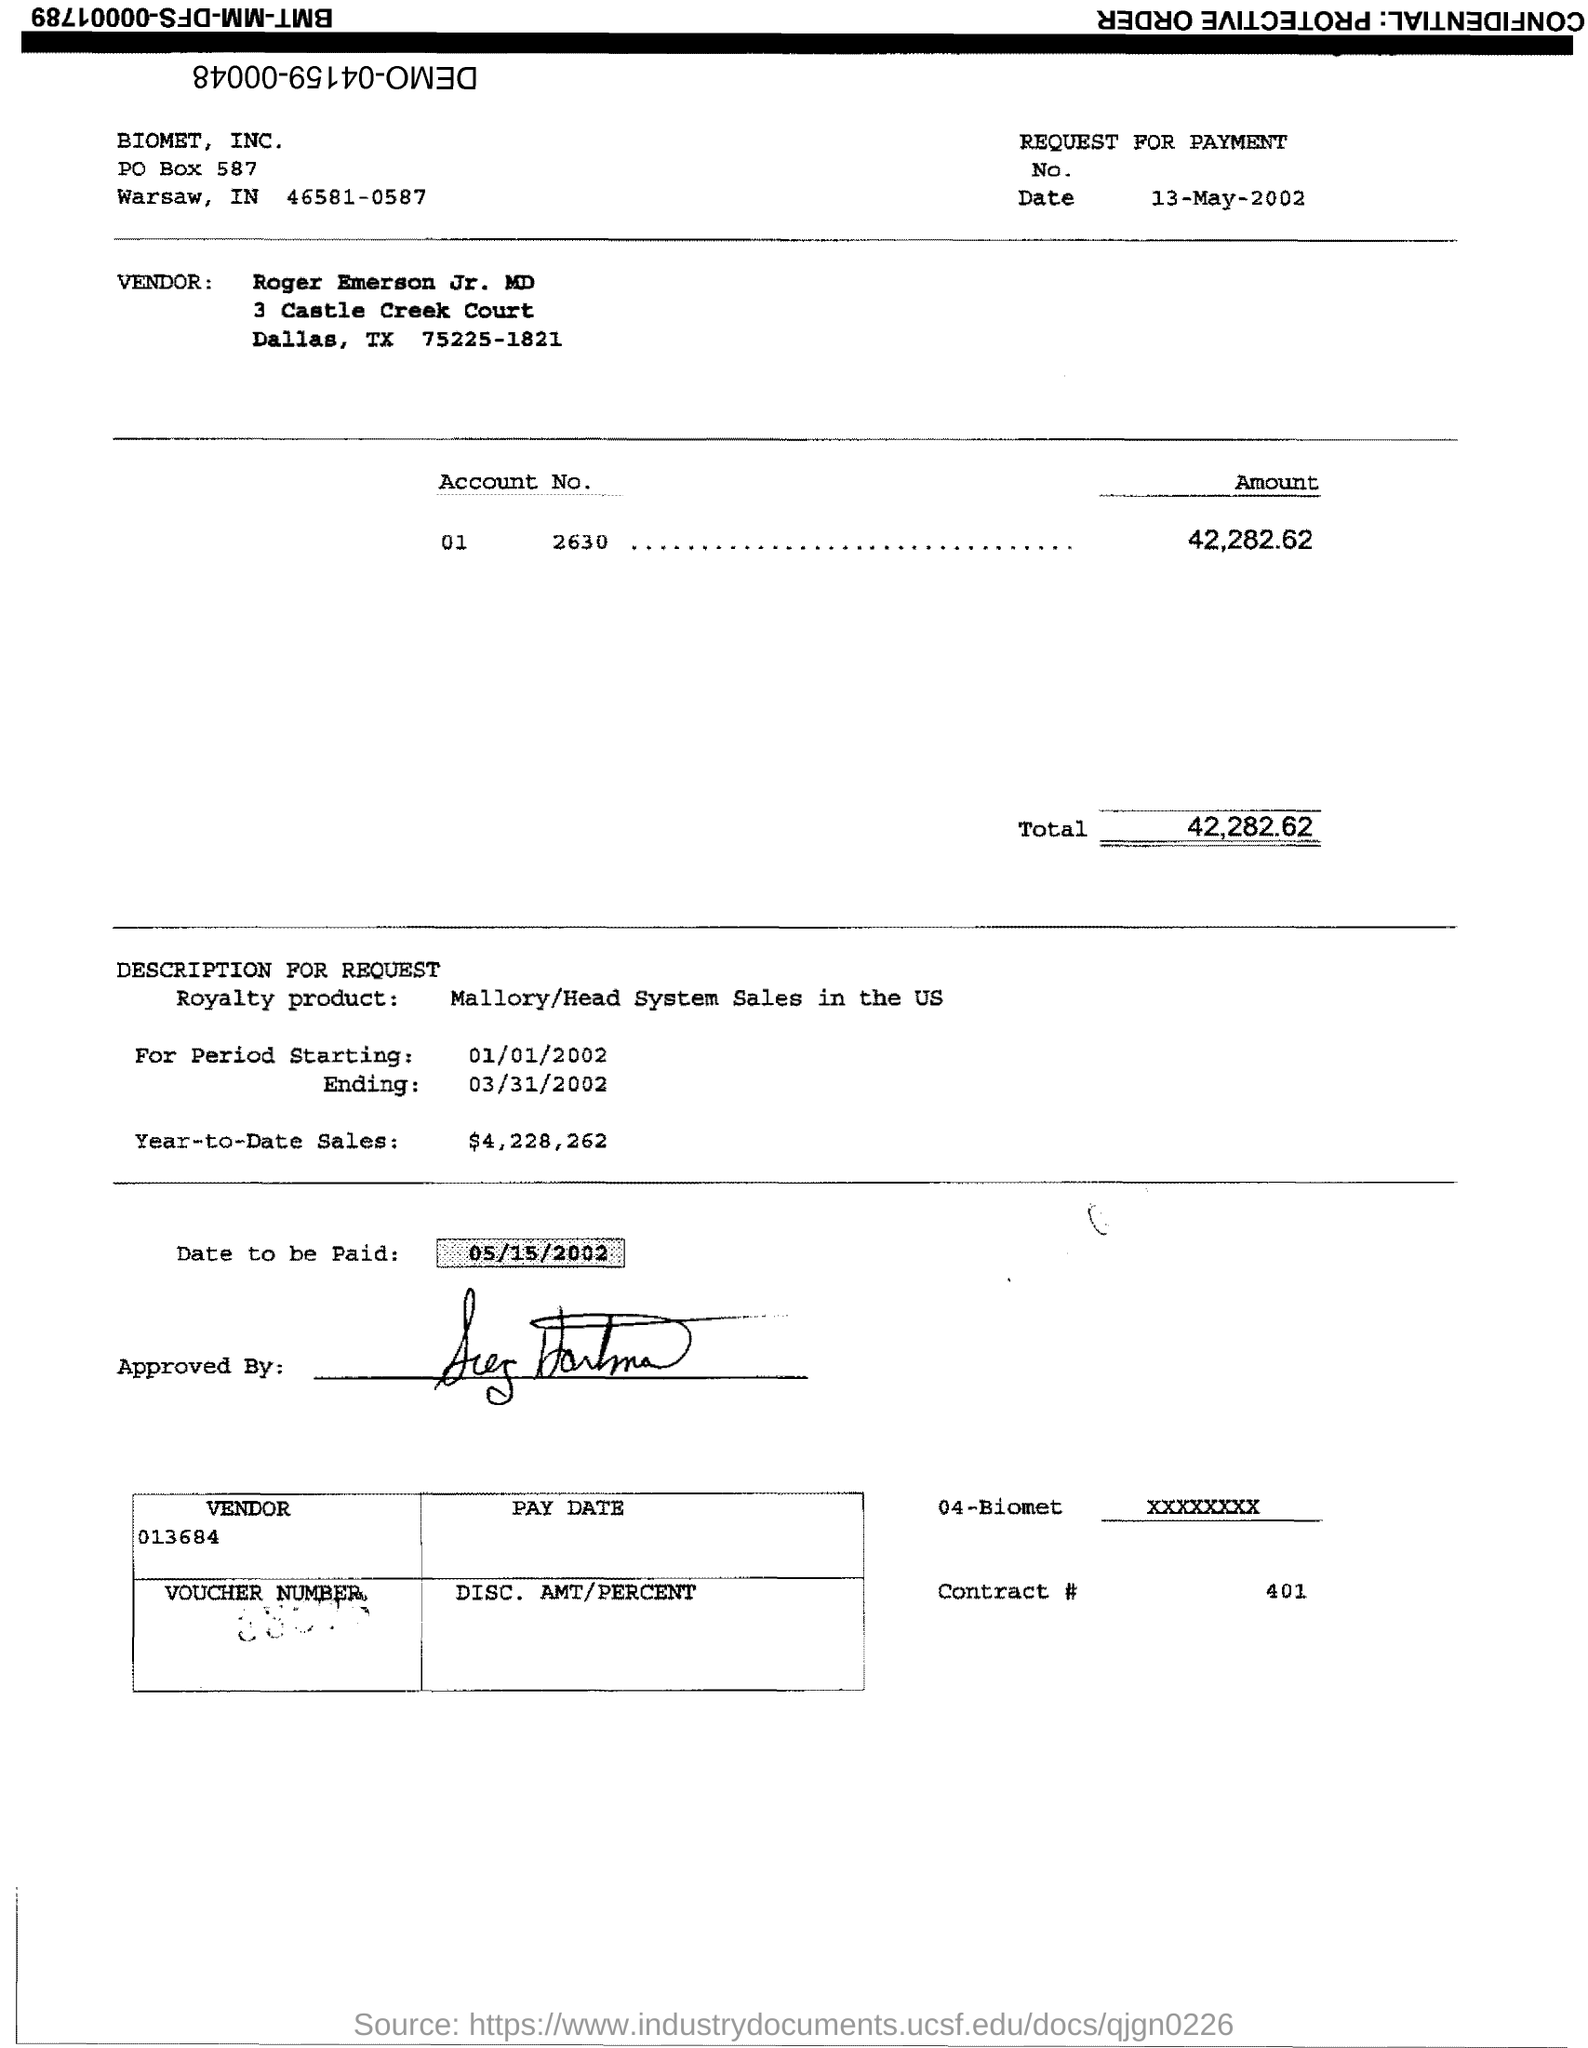Can you tell me what the document is about? The image displays a 'Request for Payment' document from Biomet Inc., detailing a total amount due of $42,282.62 for sales of a royalty product within a specified period. 